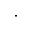<formula> <loc_0><loc_0><loc_500><loc_500>\cdot</formula> 